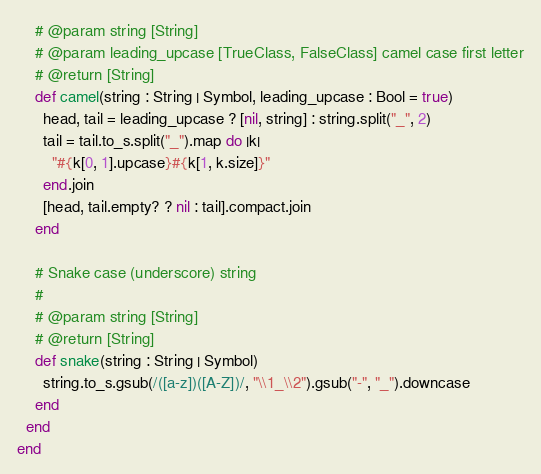Convert code to text. <code><loc_0><loc_0><loc_500><loc_500><_Crystal_>    # @param string [String]
    # @param leading_upcase [TrueClass, FalseClass] camel case first letter
    # @return [String]
    def camel(string : String | Symbol, leading_upcase : Bool = true)
      head, tail = leading_upcase ? [nil, string] : string.split("_", 2)
      tail = tail.to_s.split("_").map do |k|
        "#{k[0, 1].upcase}#{k[1, k.size]}"
      end.join
      [head, tail.empty? ? nil : tail].compact.join
    end

    # Snake case (underscore) string
    #
    # @param string [String]
    # @return [String]
    def snake(string : String | Symbol)
      string.to_s.gsub(/([a-z])([A-Z])/, "\\1_\\2").gsub("-", "_").downcase
    end
  end
end
</code> 